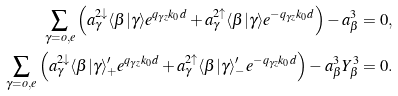Convert formula to latex. <formula><loc_0><loc_0><loc_500><loc_500>\sum _ { \gamma = o , e } \left ( a _ { \gamma } ^ { 2 \downarrow } \langle \beta | \gamma \rangle e ^ { q _ { \gamma z } k _ { 0 } d } + a _ { \gamma } ^ { 2 \uparrow } \langle \beta | \gamma \rangle e ^ { - q _ { \gamma z } k _ { 0 } d } \right ) - a _ { \beta } ^ { 3 } = 0 , \\ \sum _ { \gamma = o , e } \left ( a _ { \gamma } ^ { 2 \downarrow } \langle \beta | \gamma \rangle ^ { \prime } _ { + } e ^ { q _ { \gamma z } k _ { 0 } d } + a _ { \gamma } ^ { 2 \uparrow } \langle \beta | \gamma \rangle ^ { \prime } _ { - } e ^ { - q _ { \gamma z } k _ { 0 } d } \right ) - a _ { \beta } ^ { 3 } Y _ { \beta } ^ { 3 } = 0 .</formula> 